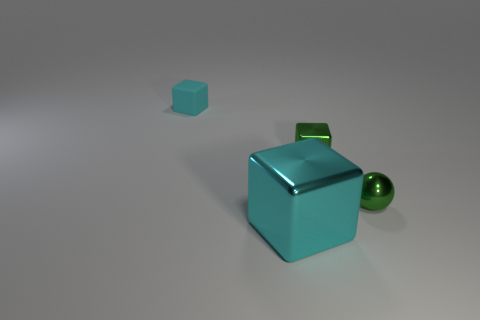Is there anything else that has the same size as the green metal block?
Your answer should be compact. Yes. There is a green object that is behind the ball; is its size the same as the cyan matte object?
Your response must be concise. Yes. There is a cyan thing behind the shiny sphere; what is its material?
Ensure brevity in your answer.  Rubber. Is there any other thing that is the same shape as the tiny cyan rubber thing?
Give a very brief answer. Yes. What number of shiny objects are tiny green cubes or yellow cylinders?
Offer a very short reply. 1. Is the number of shiny spheres that are behind the small matte block less than the number of tiny green shiny spheres?
Make the answer very short. Yes. The cyan object that is in front of the cyan object behind the small green block that is in front of the rubber thing is what shape?
Provide a short and direct response. Cube. Does the big shiny block have the same color as the rubber block?
Ensure brevity in your answer.  Yes. Is the number of big red shiny things greater than the number of rubber cubes?
Make the answer very short. No. What number of other things are there of the same material as the large thing
Provide a succinct answer. 2. 